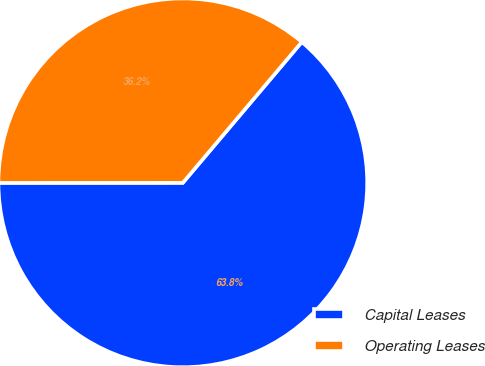<chart> <loc_0><loc_0><loc_500><loc_500><pie_chart><fcel>Capital Leases<fcel>Operating Leases<nl><fcel>63.83%<fcel>36.17%<nl></chart> 